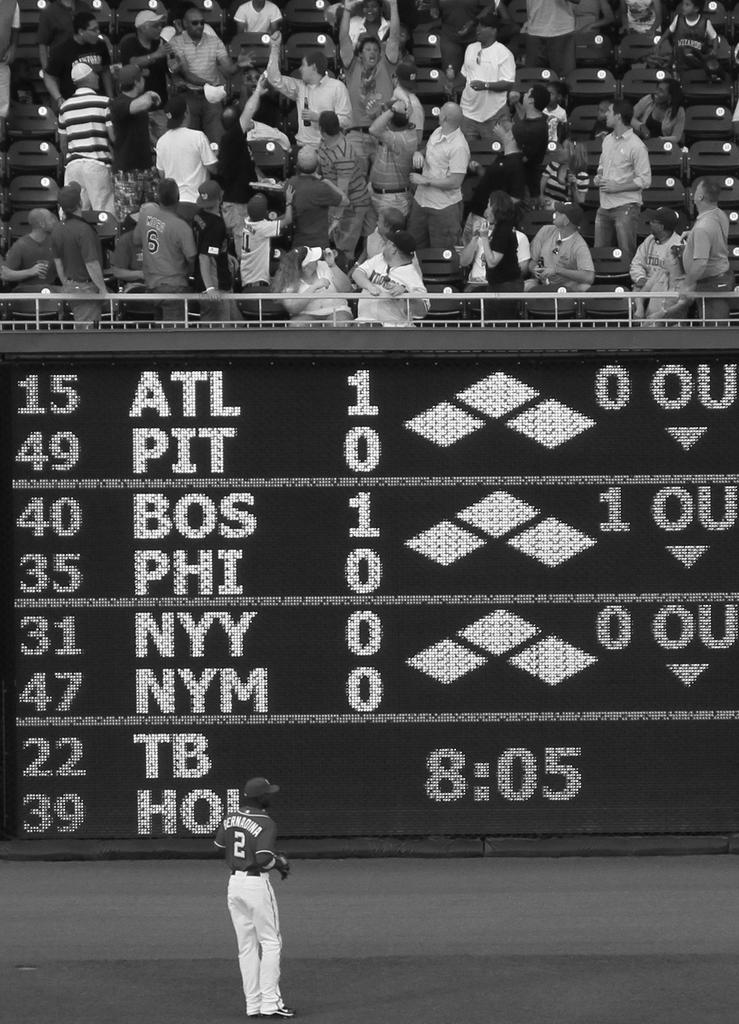<image>
Summarize the visual content of the image. A scoreboard notes the time as 8:05 and can be seen below the stadium seats. 